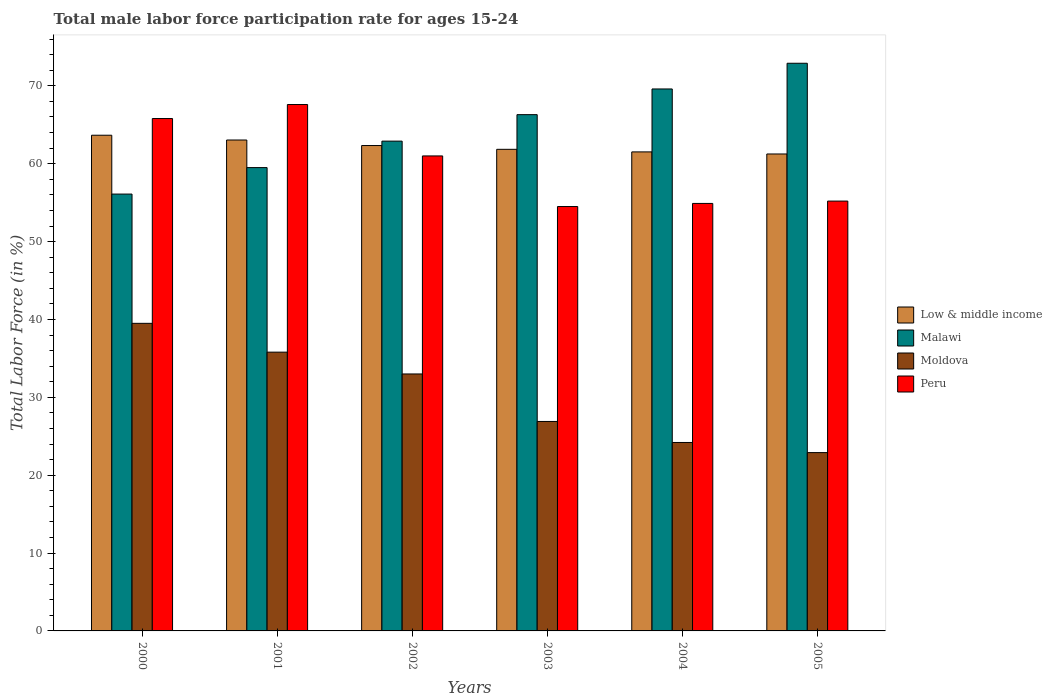Are the number of bars on each tick of the X-axis equal?
Your response must be concise. Yes. How many bars are there on the 2nd tick from the left?
Make the answer very short. 4. How many bars are there on the 1st tick from the right?
Give a very brief answer. 4. What is the label of the 1st group of bars from the left?
Ensure brevity in your answer.  2000. What is the male labor force participation rate in Low & middle income in 2004?
Provide a succinct answer. 61.52. Across all years, what is the maximum male labor force participation rate in Low & middle income?
Make the answer very short. 63.66. Across all years, what is the minimum male labor force participation rate in Malawi?
Your answer should be very brief. 56.1. In which year was the male labor force participation rate in Low & middle income maximum?
Offer a very short reply. 2000. In which year was the male labor force participation rate in Peru minimum?
Keep it short and to the point. 2003. What is the total male labor force participation rate in Moldova in the graph?
Offer a very short reply. 182.3. What is the difference between the male labor force participation rate in Low & middle income in 2000 and that in 2005?
Make the answer very short. 2.41. What is the difference between the male labor force participation rate in Moldova in 2005 and the male labor force participation rate in Low & middle income in 2001?
Give a very brief answer. -40.14. What is the average male labor force participation rate in Malawi per year?
Ensure brevity in your answer.  64.55. In the year 2003, what is the difference between the male labor force participation rate in Low & middle income and male labor force participation rate in Moldova?
Provide a succinct answer. 34.95. In how many years, is the male labor force participation rate in Low & middle income greater than 46 %?
Ensure brevity in your answer.  6. What is the ratio of the male labor force participation rate in Peru in 2003 to that in 2004?
Give a very brief answer. 0.99. Is the male labor force participation rate in Malawi in 2002 less than that in 2003?
Ensure brevity in your answer.  Yes. Is the difference between the male labor force participation rate in Low & middle income in 2001 and 2003 greater than the difference between the male labor force participation rate in Moldova in 2001 and 2003?
Provide a short and direct response. No. What is the difference between the highest and the second highest male labor force participation rate in Low & middle income?
Offer a very short reply. 0.61. What is the difference between the highest and the lowest male labor force participation rate in Low & middle income?
Offer a terse response. 2.41. Is the sum of the male labor force participation rate in Malawi in 2001 and 2005 greater than the maximum male labor force participation rate in Peru across all years?
Your response must be concise. Yes. Is it the case that in every year, the sum of the male labor force participation rate in Peru and male labor force participation rate in Low & middle income is greater than the sum of male labor force participation rate in Malawi and male labor force participation rate in Moldova?
Give a very brief answer. Yes. What does the 1st bar from the left in 2004 represents?
Ensure brevity in your answer.  Low & middle income. How many bars are there?
Provide a short and direct response. 24. What is the difference between two consecutive major ticks on the Y-axis?
Provide a succinct answer. 10. Where does the legend appear in the graph?
Provide a short and direct response. Center right. How many legend labels are there?
Keep it short and to the point. 4. What is the title of the graph?
Ensure brevity in your answer.  Total male labor force participation rate for ages 15-24. Does "Djibouti" appear as one of the legend labels in the graph?
Give a very brief answer. No. What is the label or title of the Y-axis?
Ensure brevity in your answer.  Total Labor Force (in %). What is the Total Labor Force (in %) of Low & middle income in 2000?
Keep it short and to the point. 63.66. What is the Total Labor Force (in %) in Malawi in 2000?
Offer a terse response. 56.1. What is the Total Labor Force (in %) in Moldova in 2000?
Provide a succinct answer. 39.5. What is the Total Labor Force (in %) of Peru in 2000?
Provide a succinct answer. 65.8. What is the Total Labor Force (in %) in Low & middle income in 2001?
Offer a terse response. 63.04. What is the Total Labor Force (in %) of Malawi in 2001?
Provide a succinct answer. 59.5. What is the Total Labor Force (in %) of Moldova in 2001?
Make the answer very short. 35.8. What is the Total Labor Force (in %) of Peru in 2001?
Your answer should be compact. 67.6. What is the Total Labor Force (in %) in Low & middle income in 2002?
Your answer should be very brief. 62.33. What is the Total Labor Force (in %) of Malawi in 2002?
Your answer should be compact. 62.9. What is the Total Labor Force (in %) in Low & middle income in 2003?
Offer a terse response. 61.85. What is the Total Labor Force (in %) of Malawi in 2003?
Your answer should be very brief. 66.3. What is the Total Labor Force (in %) in Moldova in 2003?
Keep it short and to the point. 26.9. What is the Total Labor Force (in %) of Peru in 2003?
Keep it short and to the point. 54.5. What is the Total Labor Force (in %) in Low & middle income in 2004?
Offer a very short reply. 61.52. What is the Total Labor Force (in %) in Malawi in 2004?
Provide a succinct answer. 69.6. What is the Total Labor Force (in %) of Moldova in 2004?
Your answer should be very brief. 24.2. What is the Total Labor Force (in %) of Peru in 2004?
Provide a short and direct response. 54.9. What is the Total Labor Force (in %) in Low & middle income in 2005?
Offer a very short reply. 61.25. What is the Total Labor Force (in %) in Malawi in 2005?
Provide a short and direct response. 72.9. What is the Total Labor Force (in %) of Moldova in 2005?
Make the answer very short. 22.9. What is the Total Labor Force (in %) in Peru in 2005?
Your answer should be very brief. 55.2. Across all years, what is the maximum Total Labor Force (in %) in Low & middle income?
Provide a short and direct response. 63.66. Across all years, what is the maximum Total Labor Force (in %) in Malawi?
Your answer should be very brief. 72.9. Across all years, what is the maximum Total Labor Force (in %) of Moldova?
Offer a terse response. 39.5. Across all years, what is the maximum Total Labor Force (in %) in Peru?
Keep it short and to the point. 67.6. Across all years, what is the minimum Total Labor Force (in %) of Low & middle income?
Offer a terse response. 61.25. Across all years, what is the minimum Total Labor Force (in %) in Malawi?
Your response must be concise. 56.1. Across all years, what is the minimum Total Labor Force (in %) in Moldova?
Offer a terse response. 22.9. Across all years, what is the minimum Total Labor Force (in %) in Peru?
Give a very brief answer. 54.5. What is the total Total Labor Force (in %) in Low & middle income in the graph?
Your answer should be very brief. 373.65. What is the total Total Labor Force (in %) in Malawi in the graph?
Your answer should be very brief. 387.3. What is the total Total Labor Force (in %) in Moldova in the graph?
Your response must be concise. 182.3. What is the total Total Labor Force (in %) in Peru in the graph?
Provide a short and direct response. 359. What is the difference between the Total Labor Force (in %) of Low & middle income in 2000 and that in 2001?
Keep it short and to the point. 0.61. What is the difference between the Total Labor Force (in %) in Low & middle income in 2000 and that in 2002?
Give a very brief answer. 1.32. What is the difference between the Total Labor Force (in %) of Malawi in 2000 and that in 2002?
Offer a terse response. -6.8. What is the difference between the Total Labor Force (in %) of Moldova in 2000 and that in 2002?
Make the answer very short. 6.5. What is the difference between the Total Labor Force (in %) in Peru in 2000 and that in 2002?
Make the answer very short. 4.8. What is the difference between the Total Labor Force (in %) of Low & middle income in 2000 and that in 2003?
Your answer should be very brief. 1.81. What is the difference between the Total Labor Force (in %) of Malawi in 2000 and that in 2003?
Make the answer very short. -10.2. What is the difference between the Total Labor Force (in %) in Moldova in 2000 and that in 2003?
Your answer should be very brief. 12.6. What is the difference between the Total Labor Force (in %) of Peru in 2000 and that in 2003?
Make the answer very short. 11.3. What is the difference between the Total Labor Force (in %) in Low & middle income in 2000 and that in 2004?
Give a very brief answer. 2.14. What is the difference between the Total Labor Force (in %) in Malawi in 2000 and that in 2004?
Ensure brevity in your answer.  -13.5. What is the difference between the Total Labor Force (in %) of Peru in 2000 and that in 2004?
Give a very brief answer. 10.9. What is the difference between the Total Labor Force (in %) of Low & middle income in 2000 and that in 2005?
Provide a succinct answer. 2.41. What is the difference between the Total Labor Force (in %) in Malawi in 2000 and that in 2005?
Offer a very short reply. -16.8. What is the difference between the Total Labor Force (in %) in Low & middle income in 2001 and that in 2002?
Give a very brief answer. 0.71. What is the difference between the Total Labor Force (in %) of Moldova in 2001 and that in 2002?
Keep it short and to the point. 2.8. What is the difference between the Total Labor Force (in %) of Low & middle income in 2001 and that in 2003?
Your answer should be compact. 1.2. What is the difference between the Total Labor Force (in %) in Malawi in 2001 and that in 2003?
Provide a succinct answer. -6.8. What is the difference between the Total Labor Force (in %) of Moldova in 2001 and that in 2003?
Your answer should be compact. 8.9. What is the difference between the Total Labor Force (in %) in Peru in 2001 and that in 2003?
Ensure brevity in your answer.  13.1. What is the difference between the Total Labor Force (in %) of Low & middle income in 2001 and that in 2004?
Provide a succinct answer. 1.53. What is the difference between the Total Labor Force (in %) of Malawi in 2001 and that in 2004?
Make the answer very short. -10.1. What is the difference between the Total Labor Force (in %) of Peru in 2001 and that in 2004?
Keep it short and to the point. 12.7. What is the difference between the Total Labor Force (in %) in Low & middle income in 2001 and that in 2005?
Provide a succinct answer. 1.8. What is the difference between the Total Labor Force (in %) of Malawi in 2001 and that in 2005?
Your answer should be compact. -13.4. What is the difference between the Total Labor Force (in %) of Low & middle income in 2002 and that in 2003?
Provide a succinct answer. 0.49. What is the difference between the Total Labor Force (in %) in Malawi in 2002 and that in 2003?
Your answer should be compact. -3.4. What is the difference between the Total Labor Force (in %) in Low & middle income in 2002 and that in 2004?
Keep it short and to the point. 0.82. What is the difference between the Total Labor Force (in %) of Peru in 2002 and that in 2004?
Keep it short and to the point. 6.1. What is the difference between the Total Labor Force (in %) of Low & middle income in 2002 and that in 2005?
Offer a very short reply. 1.09. What is the difference between the Total Labor Force (in %) of Moldova in 2002 and that in 2005?
Keep it short and to the point. 10.1. What is the difference between the Total Labor Force (in %) of Low & middle income in 2003 and that in 2004?
Provide a short and direct response. 0.33. What is the difference between the Total Labor Force (in %) in Low & middle income in 2003 and that in 2005?
Provide a succinct answer. 0.6. What is the difference between the Total Labor Force (in %) of Peru in 2003 and that in 2005?
Offer a terse response. -0.7. What is the difference between the Total Labor Force (in %) of Low & middle income in 2004 and that in 2005?
Give a very brief answer. 0.27. What is the difference between the Total Labor Force (in %) in Moldova in 2004 and that in 2005?
Offer a terse response. 1.3. What is the difference between the Total Labor Force (in %) of Peru in 2004 and that in 2005?
Provide a short and direct response. -0.3. What is the difference between the Total Labor Force (in %) of Low & middle income in 2000 and the Total Labor Force (in %) of Malawi in 2001?
Your answer should be very brief. 4.16. What is the difference between the Total Labor Force (in %) in Low & middle income in 2000 and the Total Labor Force (in %) in Moldova in 2001?
Your answer should be very brief. 27.86. What is the difference between the Total Labor Force (in %) of Low & middle income in 2000 and the Total Labor Force (in %) of Peru in 2001?
Offer a terse response. -3.94. What is the difference between the Total Labor Force (in %) in Malawi in 2000 and the Total Labor Force (in %) in Moldova in 2001?
Ensure brevity in your answer.  20.3. What is the difference between the Total Labor Force (in %) of Moldova in 2000 and the Total Labor Force (in %) of Peru in 2001?
Give a very brief answer. -28.1. What is the difference between the Total Labor Force (in %) of Low & middle income in 2000 and the Total Labor Force (in %) of Malawi in 2002?
Your answer should be very brief. 0.76. What is the difference between the Total Labor Force (in %) of Low & middle income in 2000 and the Total Labor Force (in %) of Moldova in 2002?
Your answer should be very brief. 30.66. What is the difference between the Total Labor Force (in %) of Low & middle income in 2000 and the Total Labor Force (in %) of Peru in 2002?
Keep it short and to the point. 2.66. What is the difference between the Total Labor Force (in %) in Malawi in 2000 and the Total Labor Force (in %) in Moldova in 2002?
Your answer should be compact. 23.1. What is the difference between the Total Labor Force (in %) in Malawi in 2000 and the Total Labor Force (in %) in Peru in 2002?
Your response must be concise. -4.9. What is the difference between the Total Labor Force (in %) in Moldova in 2000 and the Total Labor Force (in %) in Peru in 2002?
Give a very brief answer. -21.5. What is the difference between the Total Labor Force (in %) of Low & middle income in 2000 and the Total Labor Force (in %) of Malawi in 2003?
Make the answer very short. -2.64. What is the difference between the Total Labor Force (in %) in Low & middle income in 2000 and the Total Labor Force (in %) in Moldova in 2003?
Make the answer very short. 36.76. What is the difference between the Total Labor Force (in %) in Low & middle income in 2000 and the Total Labor Force (in %) in Peru in 2003?
Provide a short and direct response. 9.16. What is the difference between the Total Labor Force (in %) of Malawi in 2000 and the Total Labor Force (in %) of Moldova in 2003?
Keep it short and to the point. 29.2. What is the difference between the Total Labor Force (in %) of Low & middle income in 2000 and the Total Labor Force (in %) of Malawi in 2004?
Provide a succinct answer. -5.94. What is the difference between the Total Labor Force (in %) of Low & middle income in 2000 and the Total Labor Force (in %) of Moldova in 2004?
Your answer should be compact. 39.46. What is the difference between the Total Labor Force (in %) in Low & middle income in 2000 and the Total Labor Force (in %) in Peru in 2004?
Your answer should be compact. 8.76. What is the difference between the Total Labor Force (in %) in Malawi in 2000 and the Total Labor Force (in %) in Moldova in 2004?
Your answer should be compact. 31.9. What is the difference between the Total Labor Force (in %) of Moldova in 2000 and the Total Labor Force (in %) of Peru in 2004?
Keep it short and to the point. -15.4. What is the difference between the Total Labor Force (in %) in Low & middle income in 2000 and the Total Labor Force (in %) in Malawi in 2005?
Your response must be concise. -9.24. What is the difference between the Total Labor Force (in %) of Low & middle income in 2000 and the Total Labor Force (in %) of Moldova in 2005?
Provide a succinct answer. 40.76. What is the difference between the Total Labor Force (in %) in Low & middle income in 2000 and the Total Labor Force (in %) in Peru in 2005?
Keep it short and to the point. 8.46. What is the difference between the Total Labor Force (in %) of Malawi in 2000 and the Total Labor Force (in %) of Moldova in 2005?
Provide a succinct answer. 33.2. What is the difference between the Total Labor Force (in %) in Moldova in 2000 and the Total Labor Force (in %) in Peru in 2005?
Your answer should be compact. -15.7. What is the difference between the Total Labor Force (in %) of Low & middle income in 2001 and the Total Labor Force (in %) of Malawi in 2002?
Offer a very short reply. 0.14. What is the difference between the Total Labor Force (in %) in Low & middle income in 2001 and the Total Labor Force (in %) in Moldova in 2002?
Your response must be concise. 30.04. What is the difference between the Total Labor Force (in %) in Low & middle income in 2001 and the Total Labor Force (in %) in Peru in 2002?
Provide a succinct answer. 2.04. What is the difference between the Total Labor Force (in %) in Malawi in 2001 and the Total Labor Force (in %) in Moldova in 2002?
Make the answer very short. 26.5. What is the difference between the Total Labor Force (in %) of Moldova in 2001 and the Total Labor Force (in %) of Peru in 2002?
Offer a terse response. -25.2. What is the difference between the Total Labor Force (in %) in Low & middle income in 2001 and the Total Labor Force (in %) in Malawi in 2003?
Your response must be concise. -3.26. What is the difference between the Total Labor Force (in %) of Low & middle income in 2001 and the Total Labor Force (in %) of Moldova in 2003?
Keep it short and to the point. 36.14. What is the difference between the Total Labor Force (in %) of Low & middle income in 2001 and the Total Labor Force (in %) of Peru in 2003?
Provide a succinct answer. 8.54. What is the difference between the Total Labor Force (in %) of Malawi in 2001 and the Total Labor Force (in %) of Moldova in 2003?
Ensure brevity in your answer.  32.6. What is the difference between the Total Labor Force (in %) in Moldova in 2001 and the Total Labor Force (in %) in Peru in 2003?
Offer a terse response. -18.7. What is the difference between the Total Labor Force (in %) in Low & middle income in 2001 and the Total Labor Force (in %) in Malawi in 2004?
Your answer should be very brief. -6.56. What is the difference between the Total Labor Force (in %) of Low & middle income in 2001 and the Total Labor Force (in %) of Moldova in 2004?
Your response must be concise. 38.84. What is the difference between the Total Labor Force (in %) of Low & middle income in 2001 and the Total Labor Force (in %) of Peru in 2004?
Keep it short and to the point. 8.14. What is the difference between the Total Labor Force (in %) in Malawi in 2001 and the Total Labor Force (in %) in Moldova in 2004?
Offer a very short reply. 35.3. What is the difference between the Total Labor Force (in %) in Malawi in 2001 and the Total Labor Force (in %) in Peru in 2004?
Your answer should be very brief. 4.6. What is the difference between the Total Labor Force (in %) of Moldova in 2001 and the Total Labor Force (in %) of Peru in 2004?
Give a very brief answer. -19.1. What is the difference between the Total Labor Force (in %) of Low & middle income in 2001 and the Total Labor Force (in %) of Malawi in 2005?
Ensure brevity in your answer.  -9.86. What is the difference between the Total Labor Force (in %) in Low & middle income in 2001 and the Total Labor Force (in %) in Moldova in 2005?
Offer a terse response. 40.14. What is the difference between the Total Labor Force (in %) of Low & middle income in 2001 and the Total Labor Force (in %) of Peru in 2005?
Provide a short and direct response. 7.84. What is the difference between the Total Labor Force (in %) in Malawi in 2001 and the Total Labor Force (in %) in Moldova in 2005?
Offer a very short reply. 36.6. What is the difference between the Total Labor Force (in %) of Malawi in 2001 and the Total Labor Force (in %) of Peru in 2005?
Your response must be concise. 4.3. What is the difference between the Total Labor Force (in %) of Moldova in 2001 and the Total Labor Force (in %) of Peru in 2005?
Provide a succinct answer. -19.4. What is the difference between the Total Labor Force (in %) of Low & middle income in 2002 and the Total Labor Force (in %) of Malawi in 2003?
Make the answer very short. -3.97. What is the difference between the Total Labor Force (in %) of Low & middle income in 2002 and the Total Labor Force (in %) of Moldova in 2003?
Provide a short and direct response. 35.43. What is the difference between the Total Labor Force (in %) in Low & middle income in 2002 and the Total Labor Force (in %) in Peru in 2003?
Your answer should be very brief. 7.83. What is the difference between the Total Labor Force (in %) of Malawi in 2002 and the Total Labor Force (in %) of Moldova in 2003?
Keep it short and to the point. 36. What is the difference between the Total Labor Force (in %) in Malawi in 2002 and the Total Labor Force (in %) in Peru in 2003?
Your response must be concise. 8.4. What is the difference between the Total Labor Force (in %) in Moldova in 2002 and the Total Labor Force (in %) in Peru in 2003?
Your answer should be compact. -21.5. What is the difference between the Total Labor Force (in %) in Low & middle income in 2002 and the Total Labor Force (in %) in Malawi in 2004?
Give a very brief answer. -7.27. What is the difference between the Total Labor Force (in %) of Low & middle income in 2002 and the Total Labor Force (in %) of Moldova in 2004?
Your answer should be very brief. 38.13. What is the difference between the Total Labor Force (in %) of Low & middle income in 2002 and the Total Labor Force (in %) of Peru in 2004?
Offer a terse response. 7.43. What is the difference between the Total Labor Force (in %) of Malawi in 2002 and the Total Labor Force (in %) of Moldova in 2004?
Provide a short and direct response. 38.7. What is the difference between the Total Labor Force (in %) of Malawi in 2002 and the Total Labor Force (in %) of Peru in 2004?
Ensure brevity in your answer.  8. What is the difference between the Total Labor Force (in %) of Moldova in 2002 and the Total Labor Force (in %) of Peru in 2004?
Provide a succinct answer. -21.9. What is the difference between the Total Labor Force (in %) in Low & middle income in 2002 and the Total Labor Force (in %) in Malawi in 2005?
Give a very brief answer. -10.57. What is the difference between the Total Labor Force (in %) of Low & middle income in 2002 and the Total Labor Force (in %) of Moldova in 2005?
Provide a short and direct response. 39.43. What is the difference between the Total Labor Force (in %) of Low & middle income in 2002 and the Total Labor Force (in %) of Peru in 2005?
Make the answer very short. 7.13. What is the difference between the Total Labor Force (in %) in Malawi in 2002 and the Total Labor Force (in %) in Peru in 2005?
Your answer should be very brief. 7.7. What is the difference between the Total Labor Force (in %) in Moldova in 2002 and the Total Labor Force (in %) in Peru in 2005?
Provide a succinct answer. -22.2. What is the difference between the Total Labor Force (in %) of Low & middle income in 2003 and the Total Labor Force (in %) of Malawi in 2004?
Your answer should be very brief. -7.75. What is the difference between the Total Labor Force (in %) of Low & middle income in 2003 and the Total Labor Force (in %) of Moldova in 2004?
Provide a short and direct response. 37.65. What is the difference between the Total Labor Force (in %) of Low & middle income in 2003 and the Total Labor Force (in %) of Peru in 2004?
Your response must be concise. 6.95. What is the difference between the Total Labor Force (in %) of Malawi in 2003 and the Total Labor Force (in %) of Moldova in 2004?
Provide a succinct answer. 42.1. What is the difference between the Total Labor Force (in %) in Malawi in 2003 and the Total Labor Force (in %) in Peru in 2004?
Your answer should be very brief. 11.4. What is the difference between the Total Labor Force (in %) in Low & middle income in 2003 and the Total Labor Force (in %) in Malawi in 2005?
Give a very brief answer. -11.05. What is the difference between the Total Labor Force (in %) in Low & middle income in 2003 and the Total Labor Force (in %) in Moldova in 2005?
Ensure brevity in your answer.  38.95. What is the difference between the Total Labor Force (in %) of Low & middle income in 2003 and the Total Labor Force (in %) of Peru in 2005?
Ensure brevity in your answer.  6.65. What is the difference between the Total Labor Force (in %) in Malawi in 2003 and the Total Labor Force (in %) in Moldova in 2005?
Your response must be concise. 43.4. What is the difference between the Total Labor Force (in %) of Moldova in 2003 and the Total Labor Force (in %) of Peru in 2005?
Ensure brevity in your answer.  -28.3. What is the difference between the Total Labor Force (in %) in Low & middle income in 2004 and the Total Labor Force (in %) in Malawi in 2005?
Give a very brief answer. -11.38. What is the difference between the Total Labor Force (in %) of Low & middle income in 2004 and the Total Labor Force (in %) of Moldova in 2005?
Make the answer very short. 38.62. What is the difference between the Total Labor Force (in %) in Low & middle income in 2004 and the Total Labor Force (in %) in Peru in 2005?
Give a very brief answer. 6.32. What is the difference between the Total Labor Force (in %) of Malawi in 2004 and the Total Labor Force (in %) of Moldova in 2005?
Your answer should be compact. 46.7. What is the difference between the Total Labor Force (in %) of Malawi in 2004 and the Total Labor Force (in %) of Peru in 2005?
Keep it short and to the point. 14.4. What is the difference between the Total Labor Force (in %) in Moldova in 2004 and the Total Labor Force (in %) in Peru in 2005?
Provide a succinct answer. -31. What is the average Total Labor Force (in %) of Low & middle income per year?
Give a very brief answer. 62.27. What is the average Total Labor Force (in %) in Malawi per year?
Make the answer very short. 64.55. What is the average Total Labor Force (in %) in Moldova per year?
Make the answer very short. 30.38. What is the average Total Labor Force (in %) in Peru per year?
Offer a very short reply. 59.83. In the year 2000, what is the difference between the Total Labor Force (in %) of Low & middle income and Total Labor Force (in %) of Malawi?
Your response must be concise. 7.56. In the year 2000, what is the difference between the Total Labor Force (in %) of Low & middle income and Total Labor Force (in %) of Moldova?
Your answer should be very brief. 24.16. In the year 2000, what is the difference between the Total Labor Force (in %) of Low & middle income and Total Labor Force (in %) of Peru?
Offer a terse response. -2.14. In the year 2000, what is the difference between the Total Labor Force (in %) in Moldova and Total Labor Force (in %) in Peru?
Provide a short and direct response. -26.3. In the year 2001, what is the difference between the Total Labor Force (in %) of Low & middle income and Total Labor Force (in %) of Malawi?
Offer a very short reply. 3.54. In the year 2001, what is the difference between the Total Labor Force (in %) in Low & middle income and Total Labor Force (in %) in Moldova?
Offer a very short reply. 27.24. In the year 2001, what is the difference between the Total Labor Force (in %) in Low & middle income and Total Labor Force (in %) in Peru?
Your response must be concise. -4.56. In the year 2001, what is the difference between the Total Labor Force (in %) in Malawi and Total Labor Force (in %) in Moldova?
Your answer should be very brief. 23.7. In the year 2001, what is the difference between the Total Labor Force (in %) of Malawi and Total Labor Force (in %) of Peru?
Provide a succinct answer. -8.1. In the year 2001, what is the difference between the Total Labor Force (in %) of Moldova and Total Labor Force (in %) of Peru?
Your answer should be very brief. -31.8. In the year 2002, what is the difference between the Total Labor Force (in %) in Low & middle income and Total Labor Force (in %) in Malawi?
Ensure brevity in your answer.  -0.57. In the year 2002, what is the difference between the Total Labor Force (in %) of Low & middle income and Total Labor Force (in %) of Moldova?
Your answer should be compact. 29.33. In the year 2002, what is the difference between the Total Labor Force (in %) of Low & middle income and Total Labor Force (in %) of Peru?
Your answer should be compact. 1.33. In the year 2002, what is the difference between the Total Labor Force (in %) of Malawi and Total Labor Force (in %) of Moldova?
Make the answer very short. 29.9. In the year 2002, what is the difference between the Total Labor Force (in %) of Malawi and Total Labor Force (in %) of Peru?
Ensure brevity in your answer.  1.9. In the year 2003, what is the difference between the Total Labor Force (in %) of Low & middle income and Total Labor Force (in %) of Malawi?
Give a very brief answer. -4.45. In the year 2003, what is the difference between the Total Labor Force (in %) in Low & middle income and Total Labor Force (in %) in Moldova?
Provide a short and direct response. 34.95. In the year 2003, what is the difference between the Total Labor Force (in %) of Low & middle income and Total Labor Force (in %) of Peru?
Provide a succinct answer. 7.35. In the year 2003, what is the difference between the Total Labor Force (in %) in Malawi and Total Labor Force (in %) in Moldova?
Offer a very short reply. 39.4. In the year 2003, what is the difference between the Total Labor Force (in %) in Malawi and Total Labor Force (in %) in Peru?
Keep it short and to the point. 11.8. In the year 2003, what is the difference between the Total Labor Force (in %) in Moldova and Total Labor Force (in %) in Peru?
Make the answer very short. -27.6. In the year 2004, what is the difference between the Total Labor Force (in %) of Low & middle income and Total Labor Force (in %) of Malawi?
Your answer should be compact. -8.08. In the year 2004, what is the difference between the Total Labor Force (in %) of Low & middle income and Total Labor Force (in %) of Moldova?
Your answer should be compact. 37.32. In the year 2004, what is the difference between the Total Labor Force (in %) in Low & middle income and Total Labor Force (in %) in Peru?
Your response must be concise. 6.62. In the year 2004, what is the difference between the Total Labor Force (in %) in Malawi and Total Labor Force (in %) in Moldova?
Make the answer very short. 45.4. In the year 2004, what is the difference between the Total Labor Force (in %) in Moldova and Total Labor Force (in %) in Peru?
Keep it short and to the point. -30.7. In the year 2005, what is the difference between the Total Labor Force (in %) of Low & middle income and Total Labor Force (in %) of Malawi?
Give a very brief answer. -11.65. In the year 2005, what is the difference between the Total Labor Force (in %) of Low & middle income and Total Labor Force (in %) of Moldova?
Provide a succinct answer. 38.35. In the year 2005, what is the difference between the Total Labor Force (in %) of Low & middle income and Total Labor Force (in %) of Peru?
Provide a succinct answer. 6.05. In the year 2005, what is the difference between the Total Labor Force (in %) of Moldova and Total Labor Force (in %) of Peru?
Keep it short and to the point. -32.3. What is the ratio of the Total Labor Force (in %) of Low & middle income in 2000 to that in 2001?
Offer a terse response. 1.01. What is the ratio of the Total Labor Force (in %) in Malawi in 2000 to that in 2001?
Offer a terse response. 0.94. What is the ratio of the Total Labor Force (in %) of Moldova in 2000 to that in 2001?
Keep it short and to the point. 1.1. What is the ratio of the Total Labor Force (in %) in Peru in 2000 to that in 2001?
Your response must be concise. 0.97. What is the ratio of the Total Labor Force (in %) of Low & middle income in 2000 to that in 2002?
Your response must be concise. 1.02. What is the ratio of the Total Labor Force (in %) of Malawi in 2000 to that in 2002?
Keep it short and to the point. 0.89. What is the ratio of the Total Labor Force (in %) in Moldova in 2000 to that in 2002?
Make the answer very short. 1.2. What is the ratio of the Total Labor Force (in %) in Peru in 2000 to that in 2002?
Offer a terse response. 1.08. What is the ratio of the Total Labor Force (in %) of Low & middle income in 2000 to that in 2003?
Your answer should be compact. 1.03. What is the ratio of the Total Labor Force (in %) of Malawi in 2000 to that in 2003?
Provide a short and direct response. 0.85. What is the ratio of the Total Labor Force (in %) of Moldova in 2000 to that in 2003?
Your answer should be very brief. 1.47. What is the ratio of the Total Labor Force (in %) of Peru in 2000 to that in 2003?
Offer a very short reply. 1.21. What is the ratio of the Total Labor Force (in %) of Low & middle income in 2000 to that in 2004?
Provide a succinct answer. 1.03. What is the ratio of the Total Labor Force (in %) in Malawi in 2000 to that in 2004?
Keep it short and to the point. 0.81. What is the ratio of the Total Labor Force (in %) of Moldova in 2000 to that in 2004?
Make the answer very short. 1.63. What is the ratio of the Total Labor Force (in %) of Peru in 2000 to that in 2004?
Ensure brevity in your answer.  1.2. What is the ratio of the Total Labor Force (in %) of Low & middle income in 2000 to that in 2005?
Your response must be concise. 1.04. What is the ratio of the Total Labor Force (in %) in Malawi in 2000 to that in 2005?
Your answer should be compact. 0.77. What is the ratio of the Total Labor Force (in %) of Moldova in 2000 to that in 2005?
Ensure brevity in your answer.  1.72. What is the ratio of the Total Labor Force (in %) in Peru in 2000 to that in 2005?
Offer a very short reply. 1.19. What is the ratio of the Total Labor Force (in %) in Low & middle income in 2001 to that in 2002?
Your response must be concise. 1.01. What is the ratio of the Total Labor Force (in %) of Malawi in 2001 to that in 2002?
Your answer should be compact. 0.95. What is the ratio of the Total Labor Force (in %) in Moldova in 2001 to that in 2002?
Make the answer very short. 1.08. What is the ratio of the Total Labor Force (in %) in Peru in 2001 to that in 2002?
Your answer should be compact. 1.11. What is the ratio of the Total Labor Force (in %) in Low & middle income in 2001 to that in 2003?
Give a very brief answer. 1.02. What is the ratio of the Total Labor Force (in %) in Malawi in 2001 to that in 2003?
Your answer should be compact. 0.9. What is the ratio of the Total Labor Force (in %) of Moldova in 2001 to that in 2003?
Ensure brevity in your answer.  1.33. What is the ratio of the Total Labor Force (in %) in Peru in 2001 to that in 2003?
Offer a very short reply. 1.24. What is the ratio of the Total Labor Force (in %) in Low & middle income in 2001 to that in 2004?
Keep it short and to the point. 1.02. What is the ratio of the Total Labor Force (in %) of Malawi in 2001 to that in 2004?
Keep it short and to the point. 0.85. What is the ratio of the Total Labor Force (in %) of Moldova in 2001 to that in 2004?
Provide a succinct answer. 1.48. What is the ratio of the Total Labor Force (in %) in Peru in 2001 to that in 2004?
Give a very brief answer. 1.23. What is the ratio of the Total Labor Force (in %) in Low & middle income in 2001 to that in 2005?
Offer a terse response. 1.03. What is the ratio of the Total Labor Force (in %) in Malawi in 2001 to that in 2005?
Provide a short and direct response. 0.82. What is the ratio of the Total Labor Force (in %) in Moldova in 2001 to that in 2005?
Offer a terse response. 1.56. What is the ratio of the Total Labor Force (in %) in Peru in 2001 to that in 2005?
Provide a short and direct response. 1.22. What is the ratio of the Total Labor Force (in %) in Low & middle income in 2002 to that in 2003?
Offer a very short reply. 1.01. What is the ratio of the Total Labor Force (in %) in Malawi in 2002 to that in 2003?
Your response must be concise. 0.95. What is the ratio of the Total Labor Force (in %) of Moldova in 2002 to that in 2003?
Keep it short and to the point. 1.23. What is the ratio of the Total Labor Force (in %) in Peru in 2002 to that in 2003?
Make the answer very short. 1.12. What is the ratio of the Total Labor Force (in %) in Low & middle income in 2002 to that in 2004?
Offer a terse response. 1.01. What is the ratio of the Total Labor Force (in %) of Malawi in 2002 to that in 2004?
Keep it short and to the point. 0.9. What is the ratio of the Total Labor Force (in %) of Moldova in 2002 to that in 2004?
Provide a short and direct response. 1.36. What is the ratio of the Total Labor Force (in %) of Low & middle income in 2002 to that in 2005?
Ensure brevity in your answer.  1.02. What is the ratio of the Total Labor Force (in %) in Malawi in 2002 to that in 2005?
Your response must be concise. 0.86. What is the ratio of the Total Labor Force (in %) in Moldova in 2002 to that in 2005?
Provide a succinct answer. 1.44. What is the ratio of the Total Labor Force (in %) of Peru in 2002 to that in 2005?
Ensure brevity in your answer.  1.11. What is the ratio of the Total Labor Force (in %) of Low & middle income in 2003 to that in 2004?
Offer a very short reply. 1.01. What is the ratio of the Total Labor Force (in %) of Malawi in 2003 to that in 2004?
Keep it short and to the point. 0.95. What is the ratio of the Total Labor Force (in %) of Moldova in 2003 to that in 2004?
Make the answer very short. 1.11. What is the ratio of the Total Labor Force (in %) in Low & middle income in 2003 to that in 2005?
Give a very brief answer. 1.01. What is the ratio of the Total Labor Force (in %) in Malawi in 2003 to that in 2005?
Give a very brief answer. 0.91. What is the ratio of the Total Labor Force (in %) of Moldova in 2003 to that in 2005?
Keep it short and to the point. 1.17. What is the ratio of the Total Labor Force (in %) of Peru in 2003 to that in 2005?
Provide a succinct answer. 0.99. What is the ratio of the Total Labor Force (in %) of Malawi in 2004 to that in 2005?
Your answer should be very brief. 0.95. What is the ratio of the Total Labor Force (in %) in Moldova in 2004 to that in 2005?
Make the answer very short. 1.06. What is the ratio of the Total Labor Force (in %) of Peru in 2004 to that in 2005?
Offer a very short reply. 0.99. What is the difference between the highest and the second highest Total Labor Force (in %) in Low & middle income?
Offer a very short reply. 0.61. What is the difference between the highest and the second highest Total Labor Force (in %) of Malawi?
Your answer should be very brief. 3.3. What is the difference between the highest and the second highest Total Labor Force (in %) in Peru?
Provide a short and direct response. 1.8. What is the difference between the highest and the lowest Total Labor Force (in %) in Low & middle income?
Give a very brief answer. 2.41. 